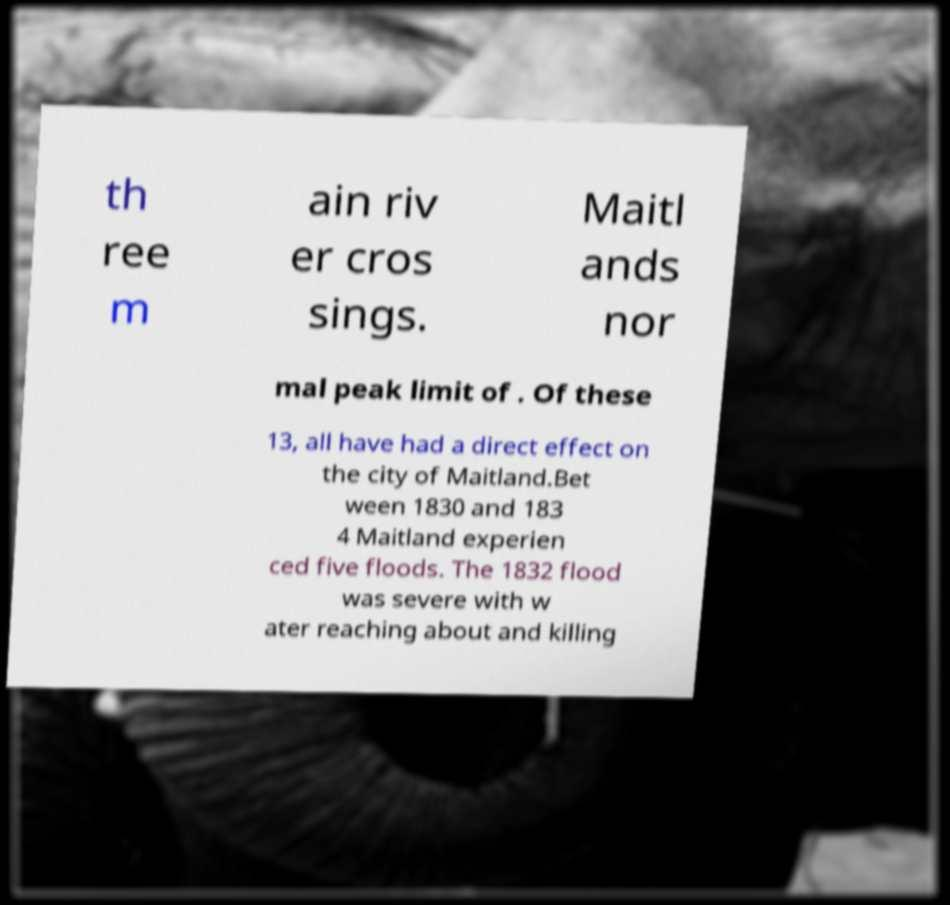Could you extract and type out the text from this image? th ree m ain riv er cros sings. Maitl ands nor mal peak limit of . Of these 13, all have had a direct effect on the city of Maitland.Bet ween 1830 and 183 4 Maitland experien ced five floods. The 1832 flood was severe with w ater reaching about and killing 